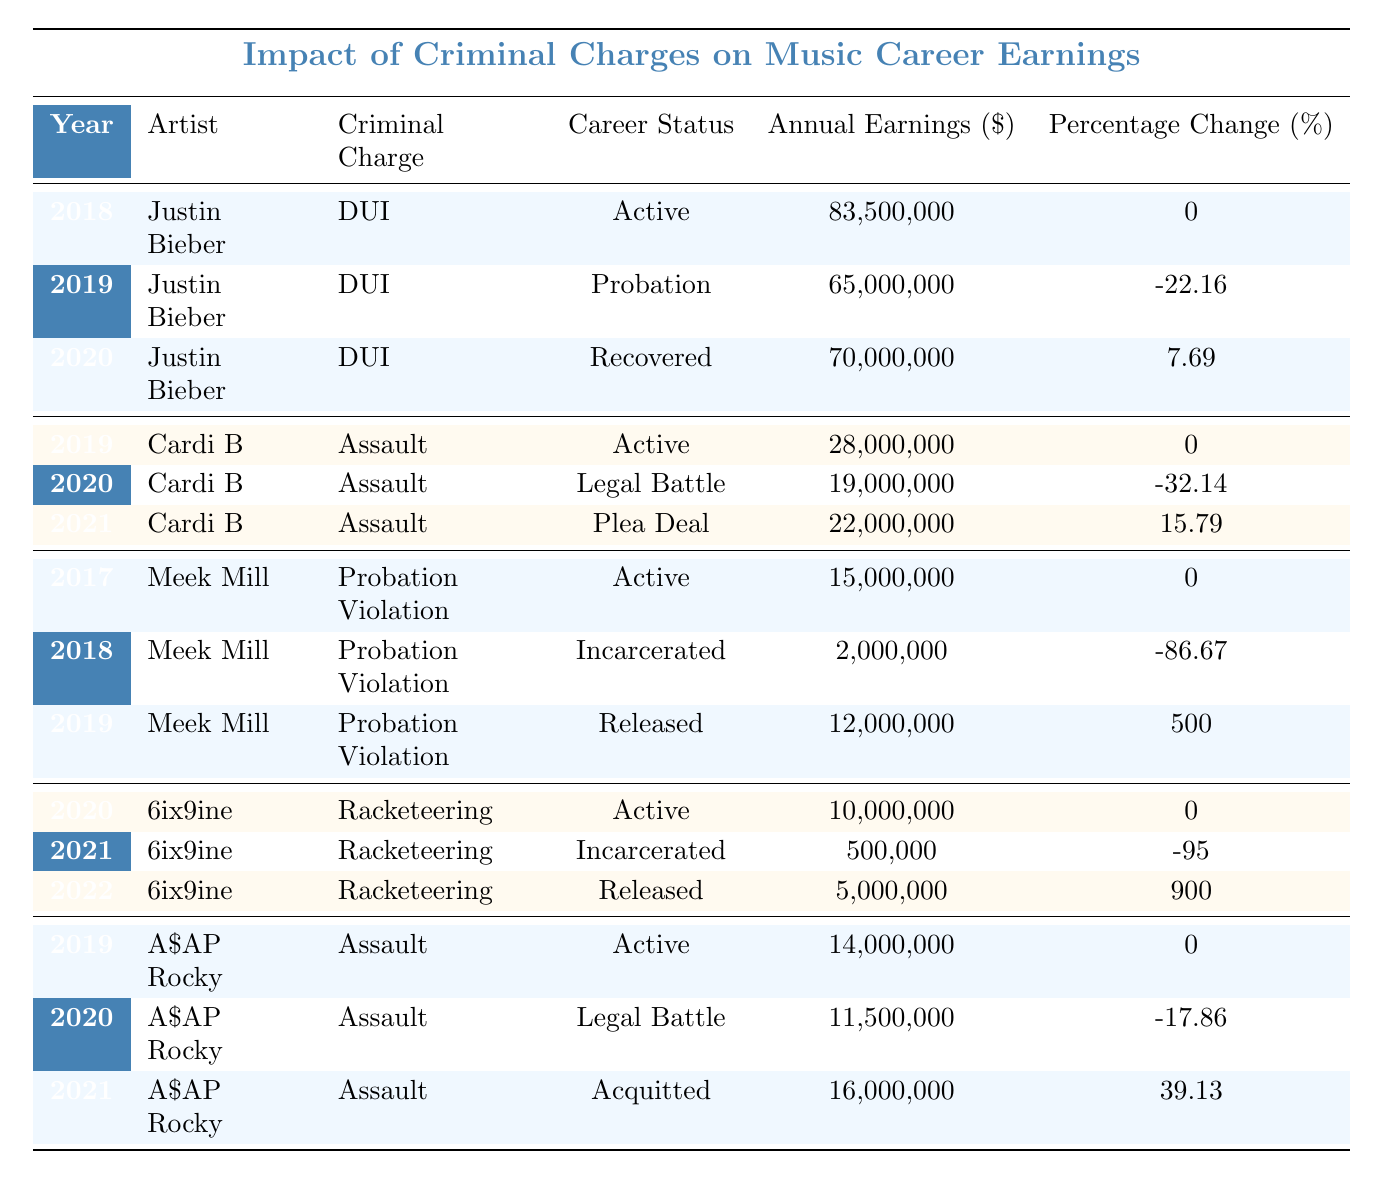What were Justin Bieber's annual earnings in 2019? According to the table, Justin Bieber's annual earnings in 2019 were $65,000,000.
Answer: 65,000,000 What was the percentage change in Cardi B's earnings from 2019 to 2020? Cardi B's earnings in 2019 were $28,000,000, and in 2020, they decreased to $19,000,000. The percentage change can be calculated as ((19 - 28) / 28) * 100 = -32.14%.
Answer: -32.14% Which artist had the highest annual earnings, and in what year? Reviewing the table, Justin Bieber had the highest annual earnings of $83,500,000 in 2018.
Answer: Justin Bieber, 2018 What was the average annual earnings of Meek Mill during the years listed? Meek Mill's earnings over the listed years are $15,000,000 (2017), $2,000,000 (2018), and $12,000,000 (2019). Adding these gives 15 + 2 + 12 = 29, and dividing by 3 gives an average of 29/3 ≈ $9,666,667.
Answer: 9,666,667 Did A$AP Rocky's earnings increase or decrease from 2020 to 2021? A$AP Rocky's earnings were $11,500,000 in 2020 and increased to $16,000,000 in 2021. This indicates an increase.
Answer: Increase What was the overall trend in earnings for 6ix9ine from 2020 to 2022? 6ix9ine earned $10,000,000 in 2020, dropped to $500,000 in 2021, then rose significantly to $5,000,000 in 2022. The trend reflects volatility with a decline followed by a recovery.
Answer: Volatile decline then recovery What was the change in earning for Cardi B from 2019 to 2021? Cardi B earned $28,000,000 in 2019 and went down to $19,000,000 in 2020, then increased to $22,000,000 in 2021. The changes are -32.14% from 2019 to 2020 and +15.79% from 2020 to 2021, indicating recovery.
Answer: Decreased, then increased Which artist faced the most significant drop in earnings in a single year, and what was the percentage? The most significant drop was for Meek Mill, whose earnings fell from $15,000,000 in 2017 to $2,000,000 in 2018, which is a decrease of 86.67%.
Answer: Meek Mill, 86.67% What is the total annual earnings of Justin Bieber over the three years shown? Justin Bieber earned $83,500,000 (2018), $65,000,000 (2019), and $70,000,000 (2020). The total is 83.5 + 65 + 70 = 218.5 million dollars.
Answer: 218,500,000 In what years did Cardi B's earnings show a decrease? Cardi B's earnings decreased in 2020 compared to 2019, and in 2021 compared to 2020, showing two years of decline.
Answer: 2020, 2021 